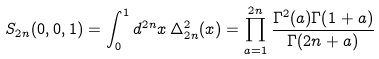Convert formula to latex. <formula><loc_0><loc_0><loc_500><loc_500>S _ { 2 n } ( 0 , 0 , 1 ) = \int _ { 0 } ^ { 1 } d ^ { 2 n } x \, \Delta _ { 2 n } ^ { 2 } ( x ) = \prod _ { a = 1 } ^ { 2 n } \frac { \Gamma ^ { 2 } ( a ) \Gamma ( 1 + a ) } { \Gamma ( 2 n + a ) }</formula> 